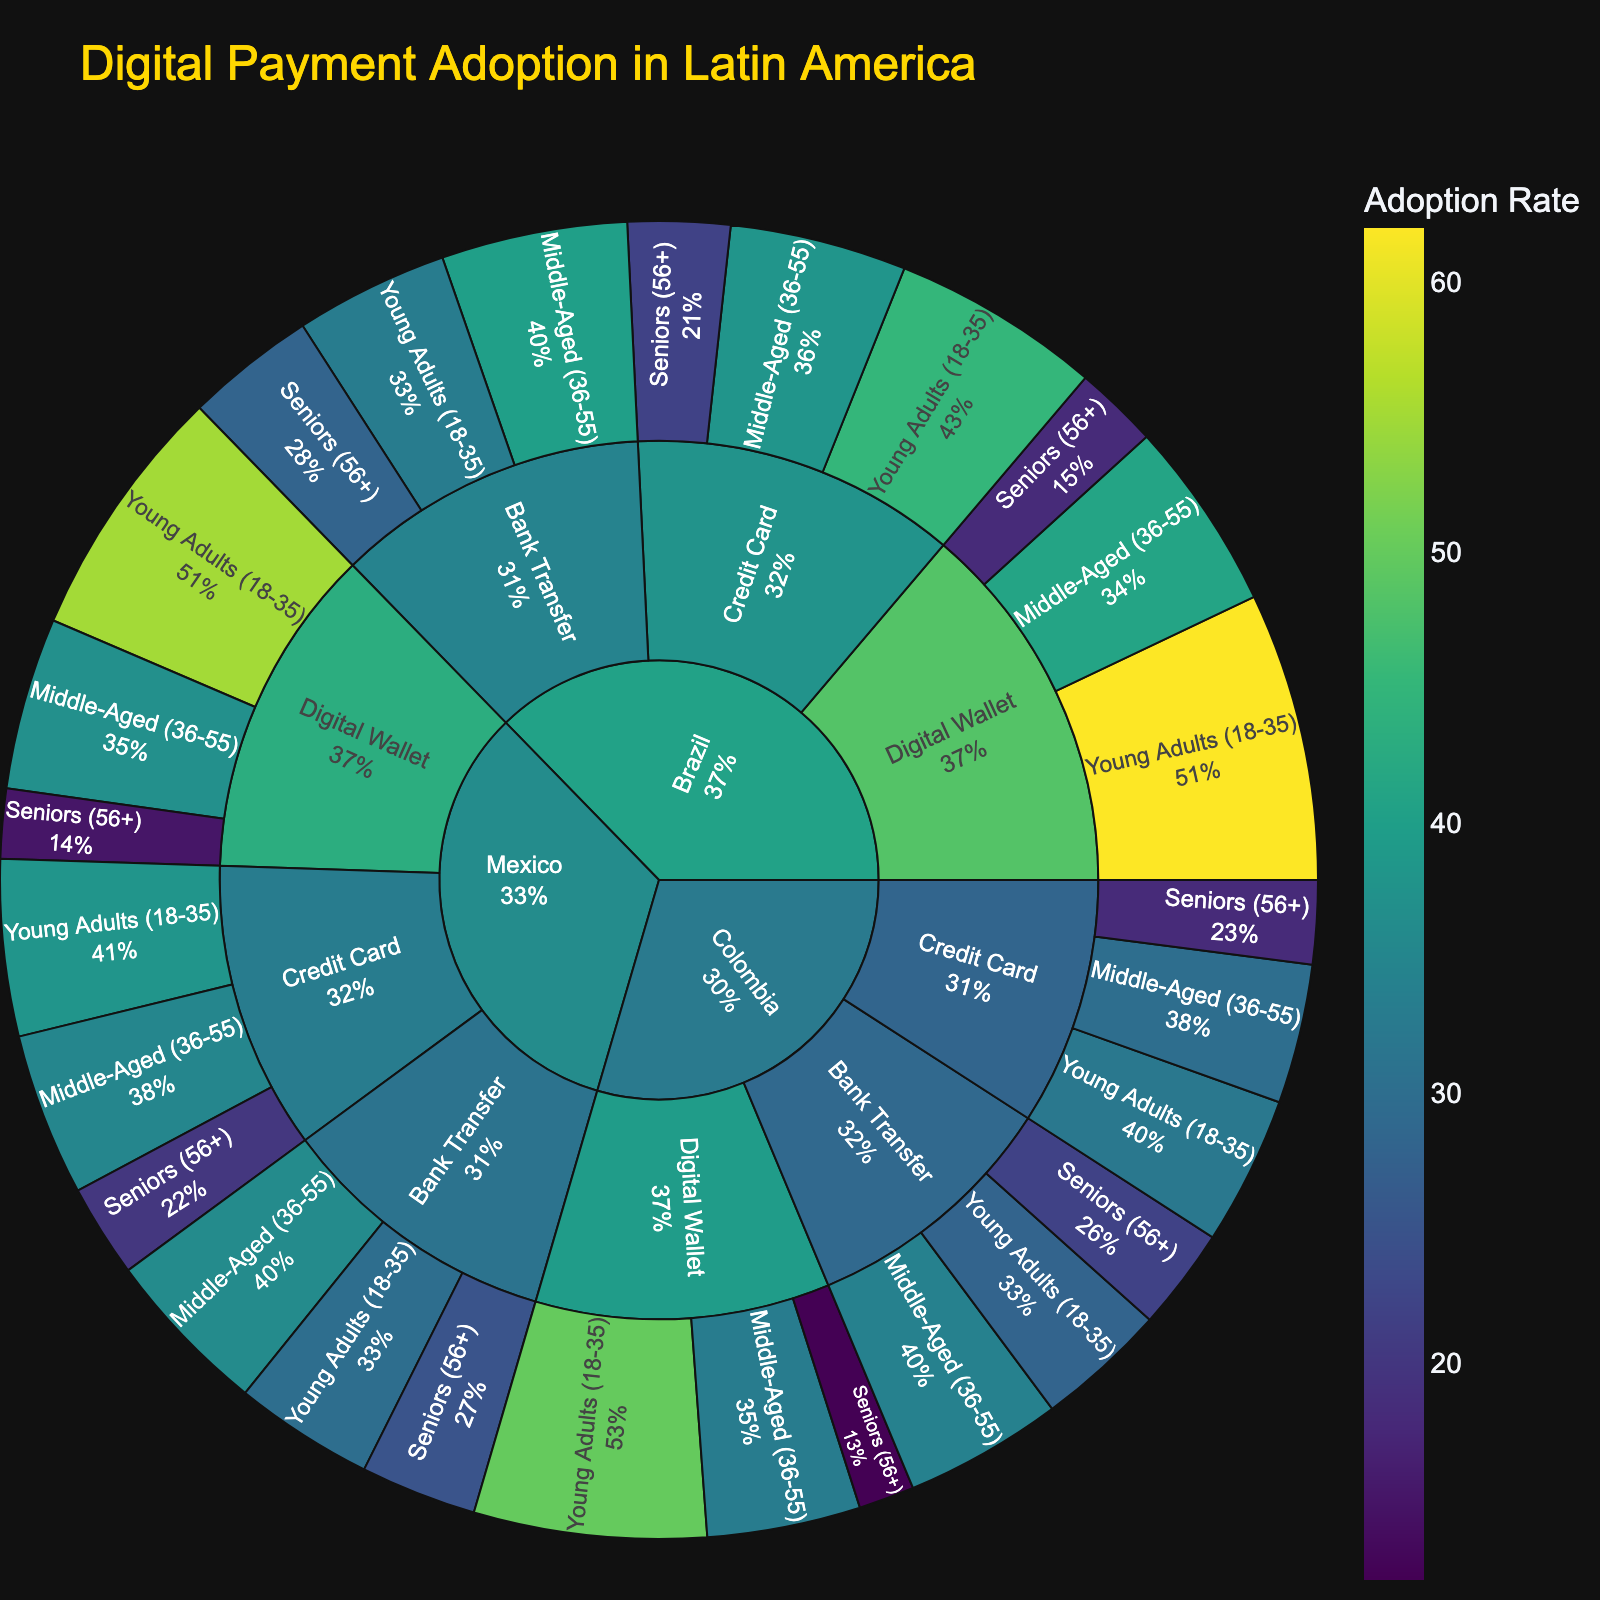What is the title of the sunburst plot? The title is displayed at the top of the plot in a bold and large font size. It summarizes the content and context of the plot, helping viewers understand what the plot represents.
Answer: Digital Payment Adoption in Latin America Which demographic group in Brazil has the highest adoption rate for Digital Wallets? By looking at the hierarchical arrangement starting from Brazil, then selecting Digital Wallet, the segment corresponding to Young Adults (18-35) shows the highest adoption rate within that category.
Answer: Young Adults (18-35) How does the adoption rate of Credit Cards in Mexico for Middle-Aged (36-55) compare to that of Seniors (56+)? Navigating through the hierarchy starting from Mexico, then Credit Card, you can compare the adoption rates for Middle-Aged (36-55) and Seniors (56+). The plot will show that Middle-Aged (36-55) has a higher rate than Seniors (56+).
Answer: Middle-Aged (36-55) has a higher rate What is the total digital payment adoption rate for Digital Wallets in Colombia? Locate Colombia in the hierarchy, then navigate to Digital Wallet. Add the adoption rates for Young Adults (18-35), Middle-Aged (36-55), and Seniors (56+). 50% + 33% + 12% = 95%
Answer: 95% Which country has the lowest adoption rate for Bank Transfer among Seniors (56+)? Check the Bank Transfer segments for Seniors (56+) among Brazil, Mexico, and Colombia. Colombia shows the lowest rate of 22%.
Answer: Colombia Summarize the adoption rate trend for Digital Wallets across different age groups in Brazil. Starting from Brazil, navigate to Digital Wallet, and observe the adoption rates for Young Adults (18-35), Middle-Aged (36-55), and Seniors (56+). The adoption rate decreases with increasing age: 62% (Young Adults), 41% (Middle-Aged), 18% (Seniors).
Answer: Decreases with age How does the adoption rate for Bank Transfers in Young Adults (18-35) differ between Brazil and Mexico? Locate the Bank Transfer segment within Brazil and Mexico, then compare the rates for Young Adults (18-35). Brazil shows 33%, whereas Mexico shows 30%.
Answer: Brazil is 3% higher than Mexico Between Credit Card and Digital Wallet, which payment method has a higher overall adoption rate in Colombia? Sum the adoption rates of all demographics (Young Adults, Middle-Aged, Seniors) for both Credit Card and Digital Wallet in Colombia. Compare the totals: Credit Card = 32% + 30% + 18% = 80%; Digital Wallet = 50% + 33% + 12% = 95%. Thus, Digital Wallet has a higher overall adoption rate.
Answer: Digital Wallet What percentage of the digital payment adoption in Brazil is accounted for by Middle-Aged (36-55) users using Bank Transfers? The value can be directly read from the segment corresponding to Brazil -> Bank Transfer -> Middle-Aged (36-55) within the plot. The adoption rate is 40%.
Answer: 40% Describe the color scheme used in the plot and its purpose. The plot uses a Viridis color scale, starting from dark blue to yellow-green. This color scheme helps in visually distinguishing the different adoption rates, where higher rates are represented by lighter colors and lower rates by darker ones.
Answer: Viridis color scale from dark blue to yellow-green 